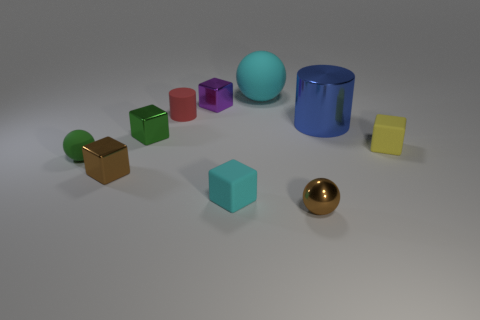Subtract all cyan blocks. How many blocks are left? 4 Subtract all cyan rubber blocks. How many blocks are left? 4 Subtract all blue cubes. Subtract all purple spheres. How many cubes are left? 5 Subtract all cylinders. How many objects are left? 8 Subtract 0 gray cubes. How many objects are left? 10 Subtract all cyan metallic things. Subtract all red rubber objects. How many objects are left? 9 Add 8 big blue metallic things. How many big blue metallic things are left? 9 Add 1 big brown shiny cylinders. How many big brown shiny cylinders exist? 1 